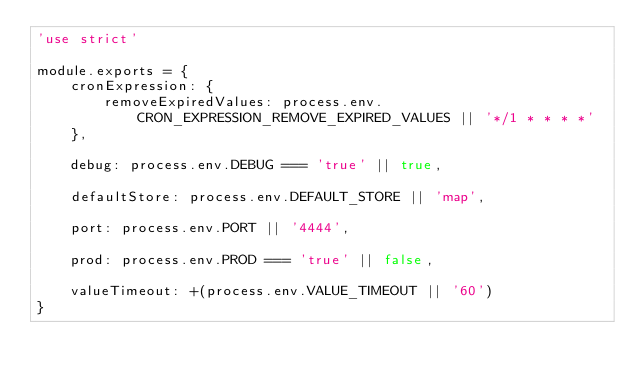<code> <loc_0><loc_0><loc_500><loc_500><_JavaScript_>'use strict'

module.exports = {
    cronExpression: {
        removeExpiredValues: process.env.CRON_EXPRESSION_REMOVE_EXPIRED_VALUES || '*/1 * * * *'
    },

    debug: process.env.DEBUG === 'true' || true,

    defaultStore: process.env.DEFAULT_STORE || 'map',

    port: process.env.PORT || '4444',

    prod: process.env.PROD === 'true' || false,

    valueTimeout: +(process.env.VALUE_TIMEOUT || '60')
}</code> 